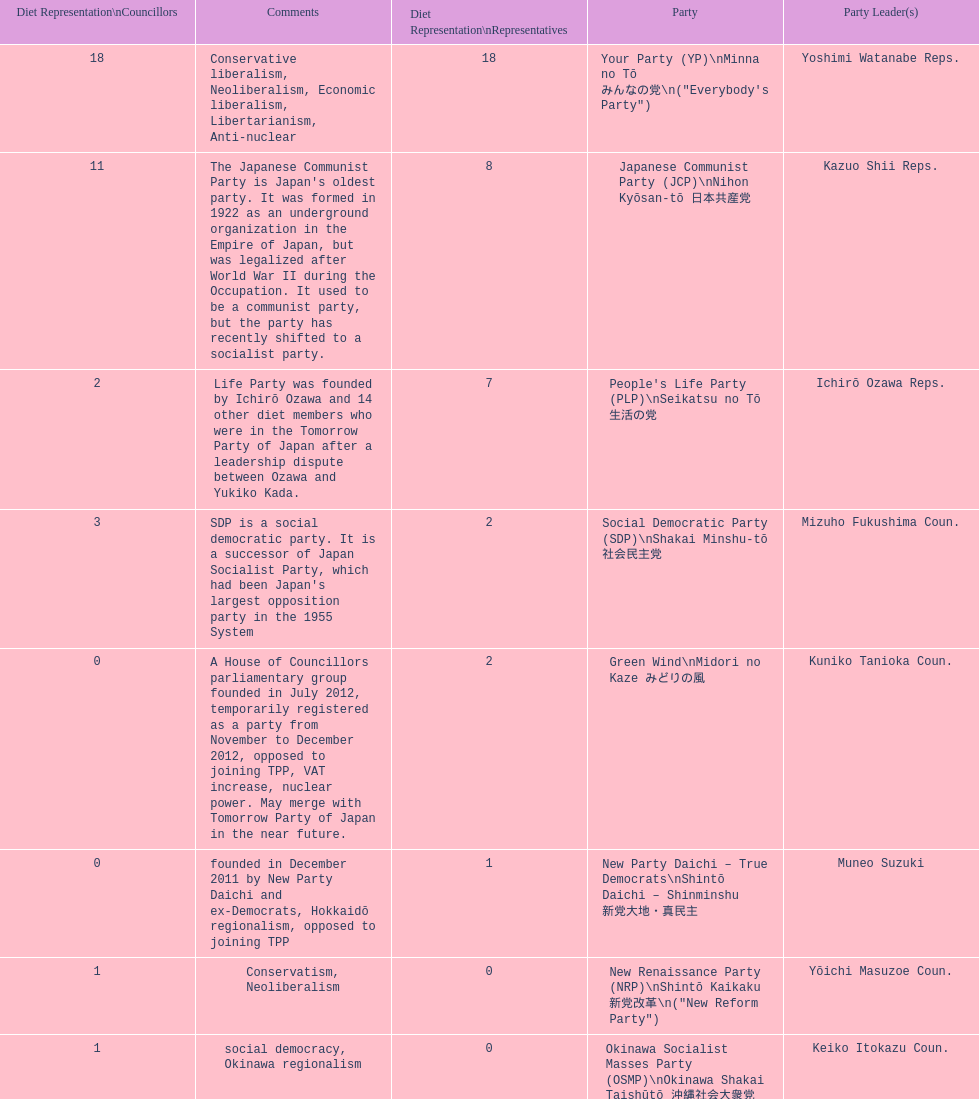What party has the most representatives in the diet representation? Your Party. 